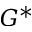Convert formula to latex. <formula><loc_0><loc_0><loc_500><loc_500>G ^ { * }</formula> 